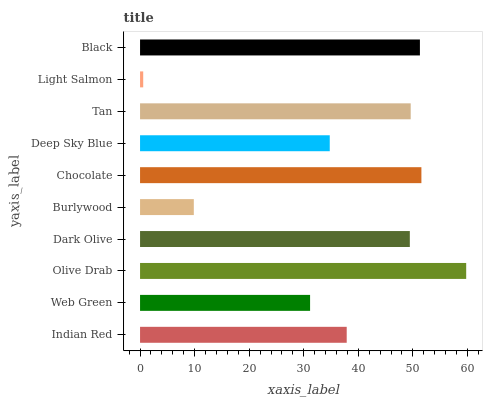Is Light Salmon the minimum?
Answer yes or no. Yes. Is Olive Drab the maximum?
Answer yes or no. Yes. Is Web Green the minimum?
Answer yes or no. No. Is Web Green the maximum?
Answer yes or no. No. Is Indian Red greater than Web Green?
Answer yes or no. Yes. Is Web Green less than Indian Red?
Answer yes or no. Yes. Is Web Green greater than Indian Red?
Answer yes or no. No. Is Indian Red less than Web Green?
Answer yes or no. No. Is Dark Olive the high median?
Answer yes or no. Yes. Is Indian Red the low median?
Answer yes or no. Yes. Is Chocolate the high median?
Answer yes or no. No. Is Burlywood the low median?
Answer yes or no. No. 